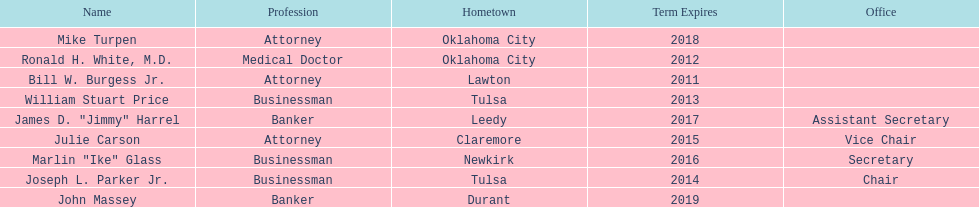Other members of the state regents from tulsa besides joseph l. parker jr. William Stuart Price. 